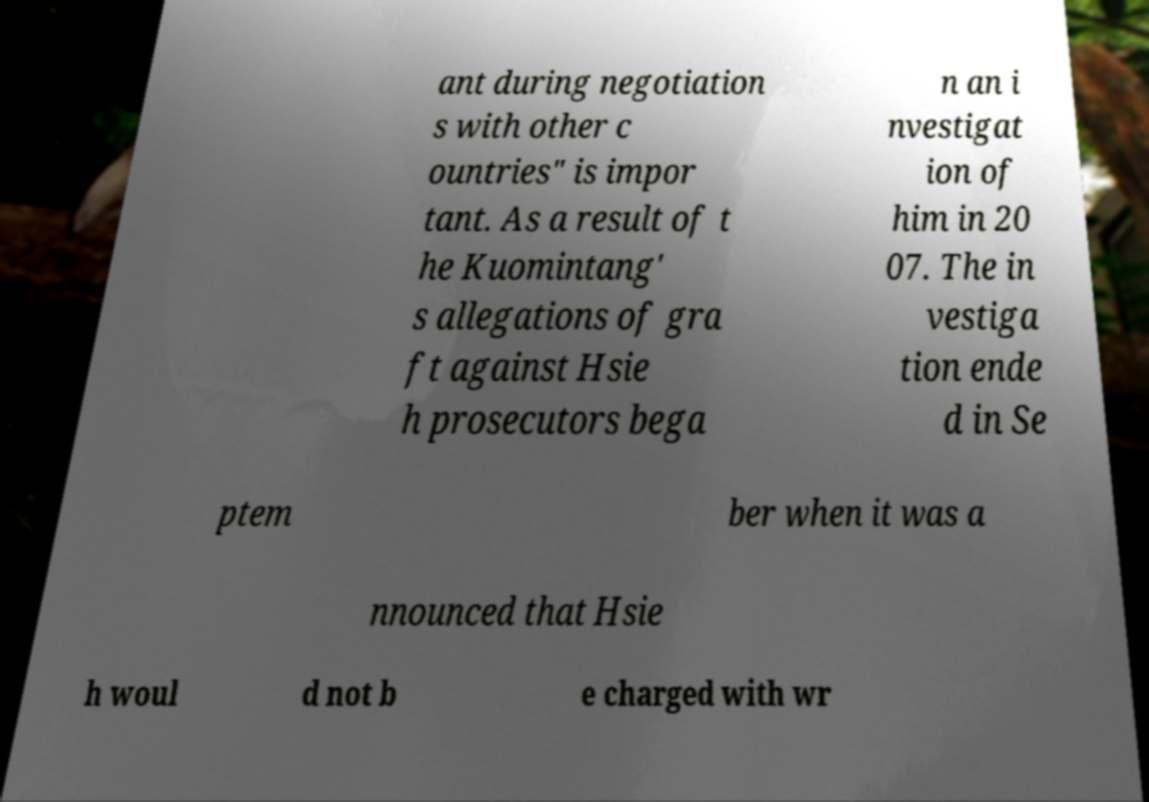Could you extract and type out the text from this image? ant during negotiation s with other c ountries" is impor tant. As a result of t he Kuomintang' s allegations of gra ft against Hsie h prosecutors bega n an i nvestigat ion of him in 20 07. The in vestiga tion ende d in Se ptem ber when it was a nnounced that Hsie h woul d not b e charged with wr 